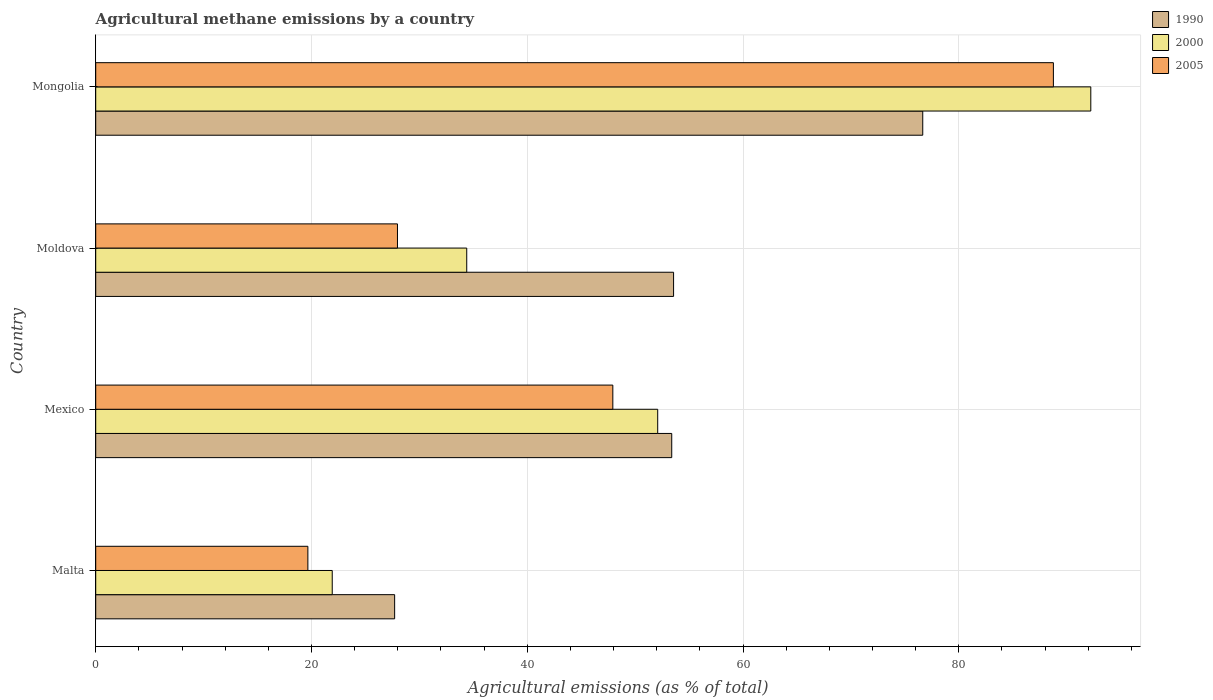How many different coloured bars are there?
Keep it short and to the point. 3. How many bars are there on the 1st tick from the top?
Offer a very short reply. 3. What is the label of the 4th group of bars from the top?
Provide a short and direct response. Malta. What is the amount of agricultural methane emitted in 2000 in Malta?
Your answer should be very brief. 21.92. Across all countries, what is the maximum amount of agricultural methane emitted in 2005?
Ensure brevity in your answer.  88.77. Across all countries, what is the minimum amount of agricultural methane emitted in 2005?
Provide a succinct answer. 19.67. In which country was the amount of agricultural methane emitted in 2005 maximum?
Offer a terse response. Mongolia. In which country was the amount of agricultural methane emitted in 2000 minimum?
Your response must be concise. Malta. What is the total amount of agricultural methane emitted in 1990 in the graph?
Offer a terse response. 211.32. What is the difference between the amount of agricultural methane emitted in 1990 in Moldova and that in Mongolia?
Your answer should be compact. -23.1. What is the difference between the amount of agricultural methane emitted in 2000 in Mongolia and the amount of agricultural methane emitted in 1990 in Mexico?
Provide a short and direct response. 38.84. What is the average amount of agricultural methane emitted in 2000 per country?
Give a very brief answer. 50.16. What is the difference between the amount of agricultural methane emitted in 2000 and amount of agricultural methane emitted in 1990 in Moldova?
Your response must be concise. -19.17. What is the ratio of the amount of agricultural methane emitted in 2000 in Malta to that in Moldova?
Keep it short and to the point. 0.64. Is the amount of agricultural methane emitted in 2005 in Malta less than that in Mongolia?
Provide a short and direct response. Yes. What is the difference between the highest and the second highest amount of agricultural methane emitted in 2005?
Offer a very short reply. 40.84. What is the difference between the highest and the lowest amount of agricultural methane emitted in 1990?
Provide a succinct answer. 48.95. Is the sum of the amount of agricultural methane emitted in 1990 in Moldova and Mongolia greater than the maximum amount of agricultural methane emitted in 2005 across all countries?
Provide a short and direct response. Yes. Is it the case that in every country, the sum of the amount of agricultural methane emitted in 2000 and amount of agricultural methane emitted in 2005 is greater than the amount of agricultural methane emitted in 1990?
Your response must be concise. Yes. How many bars are there?
Your answer should be compact. 12. Are all the bars in the graph horizontal?
Offer a very short reply. Yes. How many countries are there in the graph?
Your answer should be very brief. 4. Are the values on the major ticks of X-axis written in scientific E-notation?
Your answer should be compact. No. Does the graph contain grids?
Offer a very short reply. Yes. Where does the legend appear in the graph?
Ensure brevity in your answer.  Top right. How are the legend labels stacked?
Your response must be concise. Vertical. What is the title of the graph?
Offer a very short reply. Agricultural methane emissions by a country. Does "1998" appear as one of the legend labels in the graph?
Offer a terse response. No. What is the label or title of the X-axis?
Provide a succinct answer. Agricultural emissions (as % of total). What is the Agricultural emissions (as % of total) in 1990 in Malta?
Your answer should be compact. 27.71. What is the Agricultural emissions (as % of total) of 2000 in Malta?
Keep it short and to the point. 21.92. What is the Agricultural emissions (as % of total) of 2005 in Malta?
Provide a short and direct response. 19.67. What is the Agricultural emissions (as % of total) in 1990 in Mexico?
Your answer should be compact. 53.39. What is the Agricultural emissions (as % of total) in 2000 in Mexico?
Offer a very short reply. 52.09. What is the Agricultural emissions (as % of total) of 2005 in Mexico?
Give a very brief answer. 47.93. What is the Agricultural emissions (as % of total) of 1990 in Moldova?
Give a very brief answer. 53.56. What is the Agricultural emissions (as % of total) in 2000 in Moldova?
Offer a very short reply. 34.39. What is the Agricultural emissions (as % of total) in 2005 in Moldova?
Your answer should be very brief. 27.97. What is the Agricultural emissions (as % of total) in 1990 in Mongolia?
Keep it short and to the point. 76.66. What is the Agricultural emissions (as % of total) of 2000 in Mongolia?
Provide a short and direct response. 92.24. What is the Agricultural emissions (as % of total) of 2005 in Mongolia?
Keep it short and to the point. 88.77. Across all countries, what is the maximum Agricultural emissions (as % of total) in 1990?
Your response must be concise. 76.66. Across all countries, what is the maximum Agricultural emissions (as % of total) in 2000?
Keep it short and to the point. 92.24. Across all countries, what is the maximum Agricultural emissions (as % of total) in 2005?
Your answer should be compact. 88.77. Across all countries, what is the minimum Agricultural emissions (as % of total) of 1990?
Provide a succinct answer. 27.71. Across all countries, what is the minimum Agricultural emissions (as % of total) in 2000?
Provide a succinct answer. 21.92. Across all countries, what is the minimum Agricultural emissions (as % of total) of 2005?
Keep it short and to the point. 19.67. What is the total Agricultural emissions (as % of total) of 1990 in the graph?
Offer a very short reply. 211.32. What is the total Agricultural emissions (as % of total) in 2000 in the graph?
Provide a succinct answer. 200.64. What is the total Agricultural emissions (as % of total) of 2005 in the graph?
Your answer should be compact. 184.34. What is the difference between the Agricultural emissions (as % of total) of 1990 in Malta and that in Mexico?
Provide a short and direct response. -25.68. What is the difference between the Agricultural emissions (as % of total) of 2000 in Malta and that in Mexico?
Your answer should be very brief. -30.17. What is the difference between the Agricultural emissions (as % of total) in 2005 in Malta and that in Mexico?
Your response must be concise. -28.27. What is the difference between the Agricultural emissions (as % of total) in 1990 in Malta and that in Moldova?
Provide a short and direct response. -25.85. What is the difference between the Agricultural emissions (as % of total) of 2000 in Malta and that in Moldova?
Provide a succinct answer. -12.47. What is the difference between the Agricultural emissions (as % of total) of 2005 in Malta and that in Moldova?
Provide a succinct answer. -8.3. What is the difference between the Agricultural emissions (as % of total) of 1990 in Malta and that in Mongolia?
Give a very brief answer. -48.95. What is the difference between the Agricultural emissions (as % of total) of 2000 in Malta and that in Mongolia?
Your response must be concise. -70.31. What is the difference between the Agricultural emissions (as % of total) of 2005 in Malta and that in Mongolia?
Your answer should be very brief. -69.1. What is the difference between the Agricultural emissions (as % of total) of 1990 in Mexico and that in Moldova?
Provide a short and direct response. -0.17. What is the difference between the Agricultural emissions (as % of total) of 2000 in Mexico and that in Moldova?
Offer a very short reply. 17.7. What is the difference between the Agricultural emissions (as % of total) of 2005 in Mexico and that in Moldova?
Your response must be concise. 19.96. What is the difference between the Agricultural emissions (as % of total) in 1990 in Mexico and that in Mongolia?
Offer a terse response. -23.27. What is the difference between the Agricultural emissions (as % of total) in 2000 in Mexico and that in Mongolia?
Your response must be concise. -40.15. What is the difference between the Agricultural emissions (as % of total) in 2005 in Mexico and that in Mongolia?
Your response must be concise. -40.84. What is the difference between the Agricultural emissions (as % of total) of 1990 in Moldova and that in Mongolia?
Offer a very short reply. -23.1. What is the difference between the Agricultural emissions (as % of total) in 2000 in Moldova and that in Mongolia?
Provide a succinct answer. -57.85. What is the difference between the Agricultural emissions (as % of total) of 2005 in Moldova and that in Mongolia?
Your answer should be compact. -60.8. What is the difference between the Agricultural emissions (as % of total) of 1990 in Malta and the Agricultural emissions (as % of total) of 2000 in Mexico?
Your answer should be compact. -24.38. What is the difference between the Agricultural emissions (as % of total) in 1990 in Malta and the Agricultural emissions (as % of total) in 2005 in Mexico?
Ensure brevity in your answer.  -20.22. What is the difference between the Agricultural emissions (as % of total) of 2000 in Malta and the Agricultural emissions (as % of total) of 2005 in Mexico?
Provide a short and direct response. -26.01. What is the difference between the Agricultural emissions (as % of total) of 1990 in Malta and the Agricultural emissions (as % of total) of 2000 in Moldova?
Keep it short and to the point. -6.68. What is the difference between the Agricultural emissions (as % of total) in 1990 in Malta and the Agricultural emissions (as % of total) in 2005 in Moldova?
Your response must be concise. -0.26. What is the difference between the Agricultural emissions (as % of total) in 2000 in Malta and the Agricultural emissions (as % of total) in 2005 in Moldova?
Provide a succinct answer. -6.05. What is the difference between the Agricultural emissions (as % of total) in 1990 in Malta and the Agricultural emissions (as % of total) in 2000 in Mongolia?
Make the answer very short. -64.53. What is the difference between the Agricultural emissions (as % of total) of 1990 in Malta and the Agricultural emissions (as % of total) of 2005 in Mongolia?
Provide a succinct answer. -61.06. What is the difference between the Agricultural emissions (as % of total) in 2000 in Malta and the Agricultural emissions (as % of total) in 2005 in Mongolia?
Provide a succinct answer. -66.85. What is the difference between the Agricultural emissions (as % of total) of 1990 in Mexico and the Agricultural emissions (as % of total) of 2000 in Moldova?
Offer a very short reply. 19. What is the difference between the Agricultural emissions (as % of total) in 1990 in Mexico and the Agricultural emissions (as % of total) in 2005 in Moldova?
Make the answer very short. 25.42. What is the difference between the Agricultural emissions (as % of total) in 2000 in Mexico and the Agricultural emissions (as % of total) in 2005 in Moldova?
Your answer should be compact. 24.12. What is the difference between the Agricultural emissions (as % of total) in 1990 in Mexico and the Agricultural emissions (as % of total) in 2000 in Mongolia?
Give a very brief answer. -38.84. What is the difference between the Agricultural emissions (as % of total) in 1990 in Mexico and the Agricultural emissions (as % of total) in 2005 in Mongolia?
Provide a short and direct response. -35.38. What is the difference between the Agricultural emissions (as % of total) in 2000 in Mexico and the Agricultural emissions (as % of total) in 2005 in Mongolia?
Offer a very short reply. -36.68. What is the difference between the Agricultural emissions (as % of total) of 1990 in Moldova and the Agricultural emissions (as % of total) of 2000 in Mongolia?
Your answer should be compact. -38.67. What is the difference between the Agricultural emissions (as % of total) in 1990 in Moldova and the Agricultural emissions (as % of total) in 2005 in Mongolia?
Offer a terse response. -35.21. What is the difference between the Agricultural emissions (as % of total) in 2000 in Moldova and the Agricultural emissions (as % of total) in 2005 in Mongolia?
Your response must be concise. -54.38. What is the average Agricultural emissions (as % of total) of 1990 per country?
Provide a succinct answer. 52.83. What is the average Agricultural emissions (as % of total) of 2000 per country?
Provide a short and direct response. 50.16. What is the average Agricultural emissions (as % of total) in 2005 per country?
Your answer should be very brief. 46.08. What is the difference between the Agricultural emissions (as % of total) in 1990 and Agricultural emissions (as % of total) in 2000 in Malta?
Make the answer very short. 5.78. What is the difference between the Agricultural emissions (as % of total) in 1990 and Agricultural emissions (as % of total) in 2005 in Malta?
Offer a very short reply. 8.04. What is the difference between the Agricultural emissions (as % of total) in 2000 and Agricultural emissions (as % of total) in 2005 in Malta?
Your response must be concise. 2.26. What is the difference between the Agricultural emissions (as % of total) in 1990 and Agricultural emissions (as % of total) in 2000 in Mexico?
Offer a terse response. 1.3. What is the difference between the Agricultural emissions (as % of total) in 1990 and Agricultural emissions (as % of total) in 2005 in Mexico?
Make the answer very short. 5.46. What is the difference between the Agricultural emissions (as % of total) in 2000 and Agricultural emissions (as % of total) in 2005 in Mexico?
Give a very brief answer. 4.16. What is the difference between the Agricultural emissions (as % of total) of 1990 and Agricultural emissions (as % of total) of 2000 in Moldova?
Keep it short and to the point. 19.17. What is the difference between the Agricultural emissions (as % of total) of 1990 and Agricultural emissions (as % of total) of 2005 in Moldova?
Make the answer very short. 25.59. What is the difference between the Agricultural emissions (as % of total) of 2000 and Agricultural emissions (as % of total) of 2005 in Moldova?
Give a very brief answer. 6.42. What is the difference between the Agricultural emissions (as % of total) in 1990 and Agricultural emissions (as % of total) in 2000 in Mongolia?
Your answer should be compact. -15.58. What is the difference between the Agricultural emissions (as % of total) in 1990 and Agricultural emissions (as % of total) in 2005 in Mongolia?
Your answer should be very brief. -12.11. What is the difference between the Agricultural emissions (as % of total) in 2000 and Agricultural emissions (as % of total) in 2005 in Mongolia?
Your answer should be very brief. 3.47. What is the ratio of the Agricultural emissions (as % of total) in 1990 in Malta to that in Mexico?
Provide a short and direct response. 0.52. What is the ratio of the Agricultural emissions (as % of total) in 2000 in Malta to that in Mexico?
Your response must be concise. 0.42. What is the ratio of the Agricultural emissions (as % of total) of 2005 in Malta to that in Mexico?
Offer a very short reply. 0.41. What is the ratio of the Agricultural emissions (as % of total) of 1990 in Malta to that in Moldova?
Offer a terse response. 0.52. What is the ratio of the Agricultural emissions (as % of total) of 2000 in Malta to that in Moldova?
Offer a very short reply. 0.64. What is the ratio of the Agricultural emissions (as % of total) of 2005 in Malta to that in Moldova?
Ensure brevity in your answer.  0.7. What is the ratio of the Agricultural emissions (as % of total) of 1990 in Malta to that in Mongolia?
Offer a terse response. 0.36. What is the ratio of the Agricultural emissions (as % of total) in 2000 in Malta to that in Mongolia?
Give a very brief answer. 0.24. What is the ratio of the Agricultural emissions (as % of total) in 2005 in Malta to that in Mongolia?
Ensure brevity in your answer.  0.22. What is the ratio of the Agricultural emissions (as % of total) in 2000 in Mexico to that in Moldova?
Offer a very short reply. 1.51. What is the ratio of the Agricultural emissions (as % of total) in 2005 in Mexico to that in Moldova?
Your response must be concise. 1.71. What is the ratio of the Agricultural emissions (as % of total) in 1990 in Mexico to that in Mongolia?
Your answer should be very brief. 0.7. What is the ratio of the Agricultural emissions (as % of total) of 2000 in Mexico to that in Mongolia?
Provide a short and direct response. 0.56. What is the ratio of the Agricultural emissions (as % of total) in 2005 in Mexico to that in Mongolia?
Offer a very short reply. 0.54. What is the ratio of the Agricultural emissions (as % of total) in 1990 in Moldova to that in Mongolia?
Your answer should be very brief. 0.7. What is the ratio of the Agricultural emissions (as % of total) in 2000 in Moldova to that in Mongolia?
Keep it short and to the point. 0.37. What is the ratio of the Agricultural emissions (as % of total) of 2005 in Moldova to that in Mongolia?
Ensure brevity in your answer.  0.32. What is the difference between the highest and the second highest Agricultural emissions (as % of total) in 1990?
Provide a succinct answer. 23.1. What is the difference between the highest and the second highest Agricultural emissions (as % of total) in 2000?
Make the answer very short. 40.15. What is the difference between the highest and the second highest Agricultural emissions (as % of total) of 2005?
Your answer should be very brief. 40.84. What is the difference between the highest and the lowest Agricultural emissions (as % of total) of 1990?
Offer a terse response. 48.95. What is the difference between the highest and the lowest Agricultural emissions (as % of total) in 2000?
Offer a very short reply. 70.31. What is the difference between the highest and the lowest Agricultural emissions (as % of total) in 2005?
Provide a succinct answer. 69.1. 